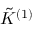Convert formula to latex. <formula><loc_0><loc_0><loc_500><loc_500>\tilde { K } ^ { ( 1 ) }</formula> 